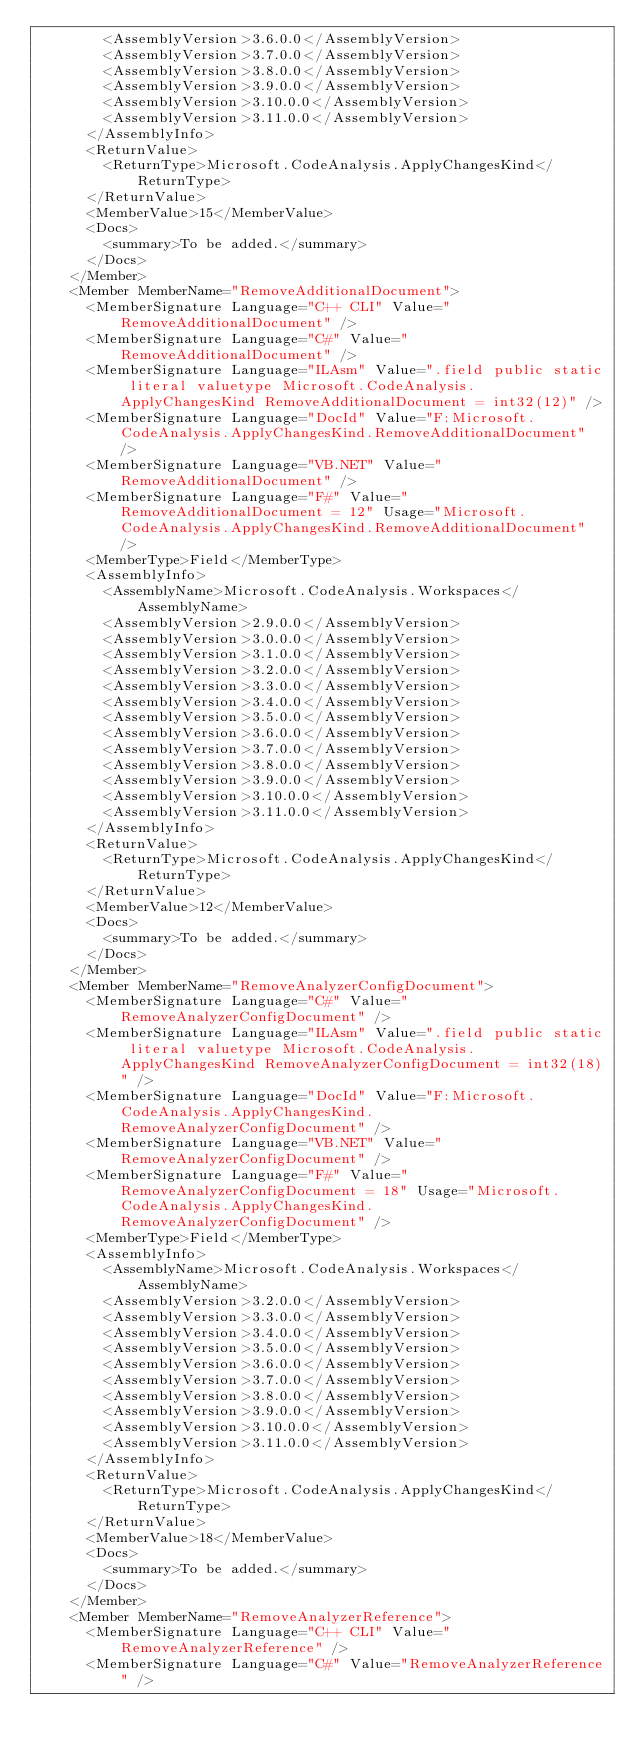<code> <loc_0><loc_0><loc_500><loc_500><_XML_>        <AssemblyVersion>3.6.0.0</AssemblyVersion>
        <AssemblyVersion>3.7.0.0</AssemblyVersion>
        <AssemblyVersion>3.8.0.0</AssemblyVersion>
        <AssemblyVersion>3.9.0.0</AssemblyVersion>
        <AssemblyVersion>3.10.0.0</AssemblyVersion>
        <AssemblyVersion>3.11.0.0</AssemblyVersion>
      </AssemblyInfo>
      <ReturnValue>
        <ReturnType>Microsoft.CodeAnalysis.ApplyChangesKind</ReturnType>
      </ReturnValue>
      <MemberValue>15</MemberValue>
      <Docs>
        <summary>To be added.</summary>
      </Docs>
    </Member>
    <Member MemberName="RemoveAdditionalDocument">
      <MemberSignature Language="C++ CLI" Value="RemoveAdditionalDocument" />
      <MemberSignature Language="C#" Value="RemoveAdditionalDocument" />
      <MemberSignature Language="ILAsm" Value=".field public static literal valuetype Microsoft.CodeAnalysis.ApplyChangesKind RemoveAdditionalDocument = int32(12)" />
      <MemberSignature Language="DocId" Value="F:Microsoft.CodeAnalysis.ApplyChangesKind.RemoveAdditionalDocument" />
      <MemberSignature Language="VB.NET" Value="RemoveAdditionalDocument" />
      <MemberSignature Language="F#" Value="RemoveAdditionalDocument = 12" Usage="Microsoft.CodeAnalysis.ApplyChangesKind.RemoveAdditionalDocument" />
      <MemberType>Field</MemberType>
      <AssemblyInfo>
        <AssemblyName>Microsoft.CodeAnalysis.Workspaces</AssemblyName>
        <AssemblyVersion>2.9.0.0</AssemblyVersion>
        <AssemblyVersion>3.0.0.0</AssemblyVersion>
        <AssemblyVersion>3.1.0.0</AssemblyVersion>
        <AssemblyVersion>3.2.0.0</AssemblyVersion>
        <AssemblyVersion>3.3.0.0</AssemblyVersion>
        <AssemblyVersion>3.4.0.0</AssemblyVersion>
        <AssemblyVersion>3.5.0.0</AssemblyVersion>
        <AssemblyVersion>3.6.0.0</AssemblyVersion>
        <AssemblyVersion>3.7.0.0</AssemblyVersion>
        <AssemblyVersion>3.8.0.0</AssemblyVersion>
        <AssemblyVersion>3.9.0.0</AssemblyVersion>
        <AssemblyVersion>3.10.0.0</AssemblyVersion>
        <AssemblyVersion>3.11.0.0</AssemblyVersion>
      </AssemblyInfo>
      <ReturnValue>
        <ReturnType>Microsoft.CodeAnalysis.ApplyChangesKind</ReturnType>
      </ReturnValue>
      <MemberValue>12</MemberValue>
      <Docs>
        <summary>To be added.</summary>
      </Docs>
    </Member>
    <Member MemberName="RemoveAnalyzerConfigDocument">
      <MemberSignature Language="C#" Value="RemoveAnalyzerConfigDocument" />
      <MemberSignature Language="ILAsm" Value=".field public static literal valuetype Microsoft.CodeAnalysis.ApplyChangesKind RemoveAnalyzerConfigDocument = int32(18)" />
      <MemberSignature Language="DocId" Value="F:Microsoft.CodeAnalysis.ApplyChangesKind.RemoveAnalyzerConfigDocument" />
      <MemberSignature Language="VB.NET" Value="RemoveAnalyzerConfigDocument" />
      <MemberSignature Language="F#" Value="RemoveAnalyzerConfigDocument = 18" Usage="Microsoft.CodeAnalysis.ApplyChangesKind.RemoveAnalyzerConfigDocument" />
      <MemberType>Field</MemberType>
      <AssemblyInfo>
        <AssemblyName>Microsoft.CodeAnalysis.Workspaces</AssemblyName>
        <AssemblyVersion>3.2.0.0</AssemblyVersion>
        <AssemblyVersion>3.3.0.0</AssemblyVersion>
        <AssemblyVersion>3.4.0.0</AssemblyVersion>
        <AssemblyVersion>3.5.0.0</AssemblyVersion>
        <AssemblyVersion>3.6.0.0</AssemblyVersion>
        <AssemblyVersion>3.7.0.0</AssemblyVersion>
        <AssemblyVersion>3.8.0.0</AssemblyVersion>
        <AssemblyVersion>3.9.0.0</AssemblyVersion>
        <AssemblyVersion>3.10.0.0</AssemblyVersion>
        <AssemblyVersion>3.11.0.0</AssemblyVersion>
      </AssemblyInfo>
      <ReturnValue>
        <ReturnType>Microsoft.CodeAnalysis.ApplyChangesKind</ReturnType>
      </ReturnValue>
      <MemberValue>18</MemberValue>
      <Docs>
        <summary>To be added.</summary>
      </Docs>
    </Member>
    <Member MemberName="RemoveAnalyzerReference">
      <MemberSignature Language="C++ CLI" Value="RemoveAnalyzerReference" />
      <MemberSignature Language="C#" Value="RemoveAnalyzerReference" /></code> 